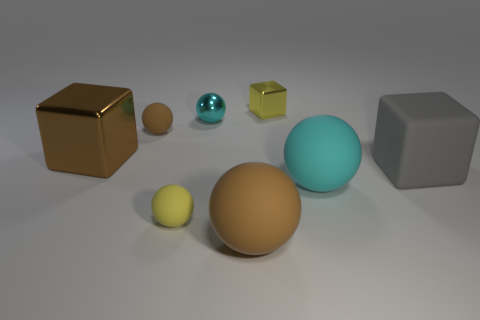Subtract all small cyan spheres. How many spheres are left? 4 Subtract all yellow spheres. How many spheres are left? 4 Add 1 big purple metal objects. How many objects exist? 9 Subtract all blue balls. Subtract all brown cylinders. How many balls are left? 5 Subtract all cubes. How many objects are left? 5 Subtract 0 purple spheres. How many objects are left? 8 Subtract all small yellow cubes. Subtract all big rubber objects. How many objects are left? 4 Add 4 gray objects. How many gray objects are left? 5 Add 3 cyan shiny things. How many cyan shiny things exist? 4 